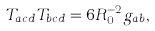<formula> <loc_0><loc_0><loc_500><loc_500>T _ { a c d } T _ { b c d } = 6 R _ { 0 } ^ { - 2 } g _ { a b } ,</formula> 